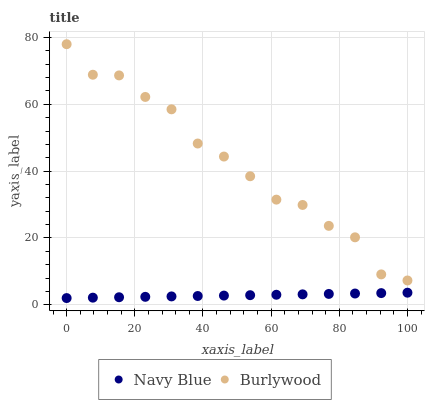Does Navy Blue have the minimum area under the curve?
Answer yes or no. Yes. Does Burlywood have the maximum area under the curve?
Answer yes or no. Yes. Does Navy Blue have the maximum area under the curve?
Answer yes or no. No. Is Navy Blue the smoothest?
Answer yes or no. Yes. Is Burlywood the roughest?
Answer yes or no. Yes. Is Navy Blue the roughest?
Answer yes or no. No. Does Navy Blue have the lowest value?
Answer yes or no. Yes. Does Burlywood have the highest value?
Answer yes or no. Yes. Does Navy Blue have the highest value?
Answer yes or no. No. Is Navy Blue less than Burlywood?
Answer yes or no. Yes. Is Burlywood greater than Navy Blue?
Answer yes or no. Yes. Does Navy Blue intersect Burlywood?
Answer yes or no. No. 